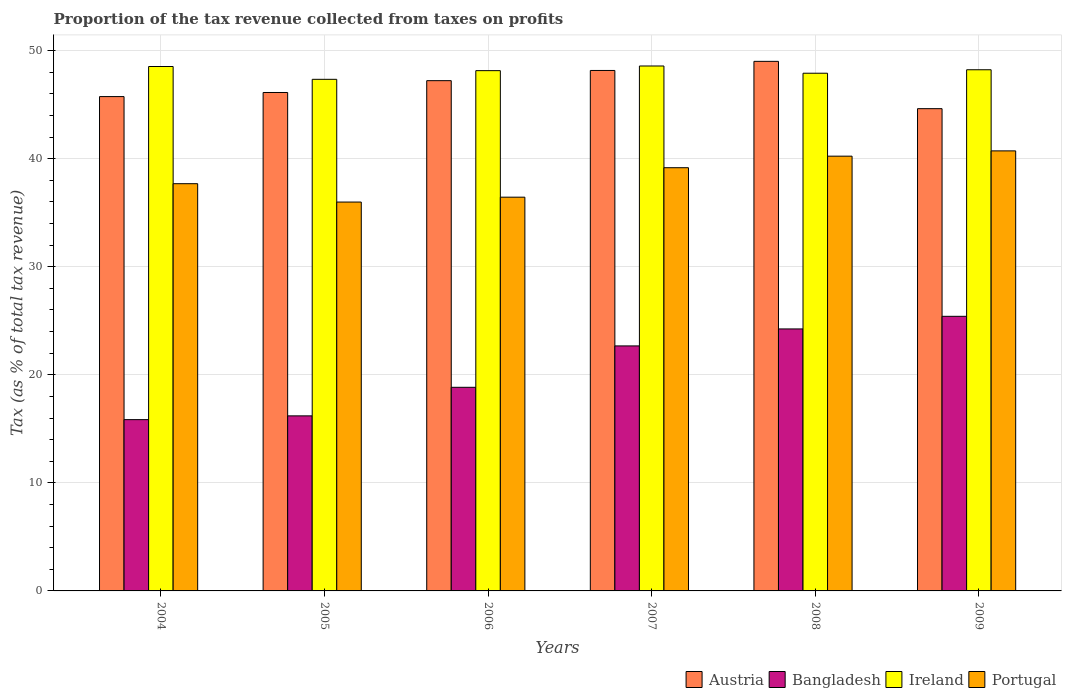How many groups of bars are there?
Your response must be concise. 6. Are the number of bars per tick equal to the number of legend labels?
Your response must be concise. Yes. Are the number of bars on each tick of the X-axis equal?
Your answer should be very brief. Yes. What is the label of the 6th group of bars from the left?
Your answer should be very brief. 2009. In how many cases, is the number of bars for a given year not equal to the number of legend labels?
Provide a short and direct response. 0. What is the proportion of the tax revenue collected in Austria in 2007?
Offer a very short reply. 48.16. Across all years, what is the maximum proportion of the tax revenue collected in Ireland?
Give a very brief answer. 48.57. Across all years, what is the minimum proportion of the tax revenue collected in Portugal?
Your answer should be very brief. 35.98. In which year was the proportion of the tax revenue collected in Ireland minimum?
Your answer should be compact. 2005. What is the total proportion of the tax revenue collected in Austria in the graph?
Provide a short and direct response. 280.87. What is the difference between the proportion of the tax revenue collected in Austria in 2004 and that in 2009?
Offer a terse response. 1.12. What is the difference between the proportion of the tax revenue collected in Ireland in 2005 and the proportion of the tax revenue collected in Portugal in 2004?
Your response must be concise. 9.66. What is the average proportion of the tax revenue collected in Austria per year?
Make the answer very short. 46.81. In the year 2009, what is the difference between the proportion of the tax revenue collected in Ireland and proportion of the tax revenue collected in Portugal?
Ensure brevity in your answer.  7.51. What is the ratio of the proportion of the tax revenue collected in Austria in 2004 to that in 2005?
Your answer should be compact. 0.99. Is the proportion of the tax revenue collected in Bangladesh in 2004 less than that in 2007?
Provide a short and direct response. Yes. Is the difference between the proportion of the tax revenue collected in Ireland in 2004 and 2006 greater than the difference between the proportion of the tax revenue collected in Portugal in 2004 and 2006?
Ensure brevity in your answer.  No. What is the difference between the highest and the second highest proportion of the tax revenue collected in Ireland?
Your answer should be very brief. 0.05. What is the difference between the highest and the lowest proportion of the tax revenue collected in Ireland?
Your answer should be compact. 1.23. Is the sum of the proportion of the tax revenue collected in Portugal in 2004 and 2006 greater than the maximum proportion of the tax revenue collected in Ireland across all years?
Your response must be concise. Yes. What does the 1st bar from the left in 2005 represents?
Ensure brevity in your answer.  Austria. How many bars are there?
Your response must be concise. 24. Are all the bars in the graph horizontal?
Ensure brevity in your answer.  No. What is the difference between two consecutive major ticks on the Y-axis?
Give a very brief answer. 10. Where does the legend appear in the graph?
Ensure brevity in your answer.  Bottom right. How many legend labels are there?
Give a very brief answer. 4. How are the legend labels stacked?
Your response must be concise. Horizontal. What is the title of the graph?
Your response must be concise. Proportion of the tax revenue collected from taxes on profits. What is the label or title of the X-axis?
Give a very brief answer. Years. What is the label or title of the Y-axis?
Provide a succinct answer. Tax (as % of total tax revenue). What is the Tax (as % of total tax revenue) of Austria in 2004?
Your response must be concise. 45.74. What is the Tax (as % of total tax revenue) in Bangladesh in 2004?
Offer a terse response. 15.85. What is the Tax (as % of total tax revenue) in Ireland in 2004?
Offer a very short reply. 48.53. What is the Tax (as % of total tax revenue) of Portugal in 2004?
Provide a succinct answer. 37.68. What is the Tax (as % of total tax revenue) of Austria in 2005?
Keep it short and to the point. 46.12. What is the Tax (as % of total tax revenue) of Bangladesh in 2005?
Ensure brevity in your answer.  16.2. What is the Tax (as % of total tax revenue) in Ireland in 2005?
Your answer should be compact. 47.34. What is the Tax (as % of total tax revenue) of Portugal in 2005?
Provide a succinct answer. 35.98. What is the Tax (as % of total tax revenue) of Austria in 2006?
Offer a terse response. 47.22. What is the Tax (as % of total tax revenue) in Bangladesh in 2006?
Provide a succinct answer. 18.84. What is the Tax (as % of total tax revenue) in Ireland in 2006?
Ensure brevity in your answer.  48.14. What is the Tax (as % of total tax revenue) of Portugal in 2006?
Ensure brevity in your answer.  36.43. What is the Tax (as % of total tax revenue) of Austria in 2007?
Provide a succinct answer. 48.16. What is the Tax (as % of total tax revenue) of Bangladesh in 2007?
Your response must be concise. 22.67. What is the Tax (as % of total tax revenue) in Ireland in 2007?
Make the answer very short. 48.57. What is the Tax (as % of total tax revenue) of Portugal in 2007?
Keep it short and to the point. 39.16. What is the Tax (as % of total tax revenue) of Austria in 2008?
Give a very brief answer. 49. What is the Tax (as % of total tax revenue) of Bangladesh in 2008?
Give a very brief answer. 24.24. What is the Tax (as % of total tax revenue) of Ireland in 2008?
Give a very brief answer. 47.9. What is the Tax (as % of total tax revenue) of Portugal in 2008?
Your answer should be very brief. 40.23. What is the Tax (as % of total tax revenue) of Austria in 2009?
Give a very brief answer. 44.63. What is the Tax (as % of total tax revenue) in Bangladesh in 2009?
Provide a succinct answer. 25.41. What is the Tax (as % of total tax revenue) in Ireland in 2009?
Ensure brevity in your answer.  48.22. What is the Tax (as % of total tax revenue) in Portugal in 2009?
Your answer should be very brief. 40.72. Across all years, what is the maximum Tax (as % of total tax revenue) of Austria?
Your answer should be compact. 49. Across all years, what is the maximum Tax (as % of total tax revenue) in Bangladesh?
Ensure brevity in your answer.  25.41. Across all years, what is the maximum Tax (as % of total tax revenue) in Ireland?
Ensure brevity in your answer.  48.57. Across all years, what is the maximum Tax (as % of total tax revenue) of Portugal?
Give a very brief answer. 40.72. Across all years, what is the minimum Tax (as % of total tax revenue) of Austria?
Provide a succinct answer. 44.63. Across all years, what is the minimum Tax (as % of total tax revenue) in Bangladesh?
Give a very brief answer. 15.85. Across all years, what is the minimum Tax (as % of total tax revenue) in Ireland?
Ensure brevity in your answer.  47.34. Across all years, what is the minimum Tax (as % of total tax revenue) of Portugal?
Provide a short and direct response. 35.98. What is the total Tax (as % of total tax revenue) in Austria in the graph?
Your answer should be compact. 280.87. What is the total Tax (as % of total tax revenue) in Bangladesh in the graph?
Offer a terse response. 123.21. What is the total Tax (as % of total tax revenue) of Ireland in the graph?
Provide a succinct answer. 288.71. What is the total Tax (as % of total tax revenue) of Portugal in the graph?
Your answer should be very brief. 230.21. What is the difference between the Tax (as % of total tax revenue) of Austria in 2004 and that in 2005?
Your response must be concise. -0.38. What is the difference between the Tax (as % of total tax revenue) of Bangladesh in 2004 and that in 2005?
Keep it short and to the point. -0.35. What is the difference between the Tax (as % of total tax revenue) in Ireland in 2004 and that in 2005?
Offer a terse response. 1.19. What is the difference between the Tax (as % of total tax revenue) of Portugal in 2004 and that in 2005?
Provide a short and direct response. 1.7. What is the difference between the Tax (as % of total tax revenue) of Austria in 2004 and that in 2006?
Make the answer very short. -1.47. What is the difference between the Tax (as % of total tax revenue) of Bangladesh in 2004 and that in 2006?
Offer a very short reply. -2.99. What is the difference between the Tax (as % of total tax revenue) of Ireland in 2004 and that in 2006?
Offer a terse response. 0.38. What is the difference between the Tax (as % of total tax revenue) of Portugal in 2004 and that in 2006?
Offer a terse response. 1.25. What is the difference between the Tax (as % of total tax revenue) in Austria in 2004 and that in 2007?
Provide a short and direct response. -2.42. What is the difference between the Tax (as % of total tax revenue) of Bangladesh in 2004 and that in 2007?
Your answer should be compact. -6.82. What is the difference between the Tax (as % of total tax revenue) of Ireland in 2004 and that in 2007?
Provide a short and direct response. -0.05. What is the difference between the Tax (as % of total tax revenue) of Portugal in 2004 and that in 2007?
Your answer should be compact. -1.48. What is the difference between the Tax (as % of total tax revenue) in Austria in 2004 and that in 2008?
Your response must be concise. -3.26. What is the difference between the Tax (as % of total tax revenue) of Bangladesh in 2004 and that in 2008?
Your response must be concise. -8.39. What is the difference between the Tax (as % of total tax revenue) of Ireland in 2004 and that in 2008?
Keep it short and to the point. 0.62. What is the difference between the Tax (as % of total tax revenue) in Portugal in 2004 and that in 2008?
Give a very brief answer. -2.55. What is the difference between the Tax (as % of total tax revenue) in Austria in 2004 and that in 2009?
Your answer should be compact. 1.12. What is the difference between the Tax (as % of total tax revenue) in Bangladesh in 2004 and that in 2009?
Offer a terse response. -9.56. What is the difference between the Tax (as % of total tax revenue) in Ireland in 2004 and that in 2009?
Your answer should be compact. 0.3. What is the difference between the Tax (as % of total tax revenue) of Portugal in 2004 and that in 2009?
Make the answer very short. -3.04. What is the difference between the Tax (as % of total tax revenue) in Austria in 2005 and that in 2006?
Ensure brevity in your answer.  -1.1. What is the difference between the Tax (as % of total tax revenue) of Bangladesh in 2005 and that in 2006?
Provide a succinct answer. -2.64. What is the difference between the Tax (as % of total tax revenue) in Ireland in 2005 and that in 2006?
Keep it short and to the point. -0.8. What is the difference between the Tax (as % of total tax revenue) in Portugal in 2005 and that in 2006?
Provide a succinct answer. -0.45. What is the difference between the Tax (as % of total tax revenue) in Austria in 2005 and that in 2007?
Give a very brief answer. -2.04. What is the difference between the Tax (as % of total tax revenue) of Bangladesh in 2005 and that in 2007?
Keep it short and to the point. -6.47. What is the difference between the Tax (as % of total tax revenue) in Ireland in 2005 and that in 2007?
Make the answer very short. -1.23. What is the difference between the Tax (as % of total tax revenue) of Portugal in 2005 and that in 2007?
Ensure brevity in your answer.  -3.18. What is the difference between the Tax (as % of total tax revenue) of Austria in 2005 and that in 2008?
Ensure brevity in your answer.  -2.88. What is the difference between the Tax (as % of total tax revenue) in Bangladesh in 2005 and that in 2008?
Your answer should be very brief. -8.04. What is the difference between the Tax (as % of total tax revenue) of Ireland in 2005 and that in 2008?
Provide a succinct answer. -0.56. What is the difference between the Tax (as % of total tax revenue) of Portugal in 2005 and that in 2008?
Give a very brief answer. -4.25. What is the difference between the Tax (as % of total tax revenue) of Austria in 2005 and that in 2009?
Offer a terse response. 1.5. What is the difference between the Tax (as % of total tax revenue) of Bangladesh in 2005 and that in 2009?
Your answer should be very brief. -9.21. What is the difference between the Tax (as % of total tax revenue) in Ireland in 2005 and that in 2009?
Ensure brevity in your answer.  -0.88. What is the difference between the Tax (as % of total tax revenue) of Portugal in 2005 and that in 2009?
Ensure brevity in your answer.  -4.73. What is the difference between the Tax (as % of total tax revenue) of Austria in 2006 and that in 2007?
Your response must be concise. -0.94. What is the difference between the Tax (as % of total tax revenue) in Bangladesh in 2006 and that in 2007?
Ensure brevity in your answer.  -3.83. What is the difference between the Tax (as % of total tax revenue) of Ireland in 2006 and that in 2007?
Make the answer very short. -0.43. What is the difference between the Tax (as % of total tax revenue) in Portugal in 2006 and that in 2007?
Offer a very short reply. -2.73. What is the difference between the Tax (as % of total tax revenue) of Austria in 2006 and that in 2008?
Provide a succinct answer. -1.79. What is the difference between the Tax (as % of total tax revenue) of Bangladesh in 2006 and that in 2008?
Your answer should be compact. -5.4. What is the difference between the Tax (as % of total tax revenue) in Ireland in 2006 and that in 2008?
Offer a very short reply. 0.24. What is the difference between the Tax (as % of total tax revenue) in Portugal in 2006 and that in 2008?
Make the answer very short. -3.8. What is the difference between the Tax (as % of total tax revenue) in Austria in 2006 and that in 2009?
Provide a short and direct response. 2.59. What is the difference between the Tax (as % of total tax revenue) in Bangladesh in 2006 and that in 2009?
Offer a terse response. -6.57. What is the difference between the Tax (as % of total tax revenue) in Ireland in 2006 and that in 2009?
Provide a succinct answer. -0.08. What is the difference between the Tax (as % of total tax revenue) of Portugal in 2006 and that in 2009?
Provide a succinct answer. -4.28. What is the difference between the Tax (as % of total tax revenue) in Austria in 2007 and that in 2008?
Make the answer very short. -0.84. What is the difference between the Tax (as % of total tax revenue) in Bangladesh in 2007 and that in 2008?
Make the answer very short. -1.57. What is the difference between the Tax (as % of total tax revenue) of Ireland in 2007 and that in 2008?
Offer a terse response. 0.67. What is the difference between the Tax (as % of total tax revenue) in Portugal in 2007 and that in 2008?
Keep it short and to the point. -1.07. What is the difference between the Tax (as % of total tax revenue) of Austria in 2007 and that in 2009?
Make the answer very short. 3.53. What is the difference between the Tax (as % of total tax revenue) of Bangladesh in 2007 and that in 2009?
Provide a short and direct response. -2.74. What is the difference between the Tax (as % of total tax revenue) of Ireland in 2007 and that in 2009?
Your response must be concise. 0.35. What is the difference between the Tax (as % of total tax revenue) in Portugal in 2007 and that in 2009?
Provide a succinct answer. -1.56. What is the difference between the Tax (as % of total tax revenue) of Austria in 2008 and that in 2009?
Give a very brief answer. 4.38. What is the difference between the Tax (as % of total tax revenue) of Bangladesh in 2008 and that in 2009?
Keep it short and to the point. -1.17. What is the difference between the Tax (as % of total tax revenue) in Ireland in 2008 and that in 2009?
Your answer should be compact. -0.32. What is the difference between the Tax (as % of total tax revenue) of Portugal in 2008 and that in 2009?
Keep it short and to the point. -0.49. What is the difference between the Tax (as % of total tax revenue) of Austria in 2004 and the Tax (as % of total tax revenue) of Bangladesh in 2005?
Make the answer very short. 29.54. What is the difference between the Tax (as % of total tax revenue) of Austria in 2004 and the Tax (as % of total tax revenue) of Ireland in 2005?
Your answer should be very brief. -1.6. What is the difference between the Tax (as % of total tax revenue) of Austria in 2004 and the Tax (as % of total tax revenue) of Portugal in 2005?
Your answer should be compact. 9.76. What is the difference between the Tax (as % of total tax revenue) of Bangladesh in 2004 and the Tax (as % of total tax revenue) of Ireland in 2005?
Make the answer very short. -31.49. What is the difference between the Tax (as % of total tax revenue) in Bangladesh in 2004 and the Tax (as % of total tax revenue) in Portugal in 2005?
Offer a terse response. -20.13. What is the difference between the Tax (as % of total tax revenue) of Ireland in 2004 and the Tax (as % of total tax revenue) of Portugal in 2005?
Give a very brief answer. 12.54. What is the difference between the Tax (as % of total tax revenue) of Austria in 2004 and the Tax (as % of total tax revenue) of Bangladesh in 2006?
Provide a short and direct response. 26.9. What is the difference between the Tax (as % of total tax revenue) in Austria in 2004 and the Tax (as % of total tax revenue) in Ireland in 2006?
Your answer should be compact. -2.4. What is the difference between the Tax (as % of total tax revenue) in Austria in 2004 and the Tax (as % of total tax revenue) in Portugal in 2006?
Provide a short and direct response. 9.31. What is the difference between the Tax (as % of total tax revenue) in Bangladesh in 2004 and the Tax (as % of total tax revenue) in Ireland in 2006?
Your answer should be compact. -32.29. What is the difference between the Tax (as % of total tax revenue) of Bangladesh in 2004 and the Tax (as % of total tax revenue) of Portugal in 2006?
Your response must be concise. -20.58. What is the difference between the Tax (as % of total tax revenue) in Ireland in 2004 and the Tax (as % of total tax revenue) in Portugal in 2006?
Your answer should be compact. 12.09. What is the difference between the Tax (as % of total tax revenue) of Austria in 2004 and the Tax (as % of total tax revenue) of Bangladesh in 2007?
Ensure brevity in your answer.  23.07. What is the difference between the Tax (as % of total tax revenue) in Austria in 2004 and the Tax (as % of total tax revenue) in Ireland in 2007?
Give a very brief answer. -2.83. What is the difference between the Tax (as % of total tax revenue) in Austria in 2004 and the Tax (as % of total tax revenue) in Portugal in 2007?
Offer a terse response. 6.58. What is the difference between the Tax (as % of total tax revenue) in Bangladesh in 2004 and the Tax (as % of total tax revenue) in Ireland in 2007?
Provide a succinct answer. -32.72. What is the difference between the Tax (as % of total tax revenue) of Bangladesh in 2004 and the Tax (as % of total tax revenue) of Portugal in 2007?
Keep it short and to the point. -23.31. What is the difference between the Tax (as % of total tax revenue) of Ireland in 2004 and the Tax (as % of total tax revenue) of Portugal in 2007?
Ensure brevity in your answer.  9.36. What is the difference between the Tax (as % of total tax revenue) in Austria in 2004 and the Tax (as % of total tax revenue) in Bangladesh in 2008?
Offer a terse response. 21.5. What is the difference between the Tax (as % of total tax revenue) in Austria in 2004 and the Tax (as % of total tax revenue) in Ireland in 2008?
Keep it short and to the point. -2.16. What is the difference between the Tax (as % of total tax revenue) of Austria in 2004 and the Tax (as % of total tax revenue) of Portugal in 2008?
Provide a succinct answer. 5.51. What is the difference between the Tax (as % of total tax revenue) of Bangladesh in 2004 and the Tax (as % of total tax revenue) of Ireland in 2008?
Give a very brief answer. -32.05. What is the difference between the Tax (as % of total tax revenue) in Bangladesh in 2004 and the Tax (as % of total tax revenue) in Portugal in 2008?
Offer a very short reply. -24.38. What is the difference between the Tax (as % of total tax revenue) of Ireland in 2004 and the Tax (as % of total tax revenue) of Portugal in 2008?
Offer a terse response. 8.3. What is the difference between the Tax (as % of total tax revenue) in Austria in 2004 and the Tax (as % of total tax revenue) in Bangladesh in 2009?
Your response must be concise. 20.33. What is the difference between the Tax (as % of total tax revenue) of Austria in 2004 and the Tax (as % of total tax revenue) of Ireland in 2009?
Provide a short and direct response. -2.48. What is the difference between the Tax (as % of total tax revenue) in Austria in 2004 and the Tax (as % of total tax revenue) in Portugal in 2009?
Make the answer very short. 5.02. What is the difference between the Tax (as % of total tax revenue) of Bangladesh in 2004 and the Tax (as % of total tax revenue) of Ireland in 2009?
Offer a terse response. -32.37. What is the difference between the Tax (as % of total tax revenue) of Bangladesh in 2004 and the Tax (as % of total tax revenue) of Portugal in 2009?
Offer a very short reply. -24.87. What is the difference between the Tax (as % of total tax revenue) of Ireland in 2004 and the Tax (as % of total tax revenue) of Portugal in 2009?
Provide a short and direct response. 7.81. What is the difference between the Tax (as % of total tax revenue) of Austria in 2005 and the Tax (as % of total tax revenue) of Bangladesh in 2006?
Offer a very short reply. 27.28. What is the difference between the Tax (as % of total tax revenue) in Austria in 2005 and the Tax (as % of total tax revenue) in Ireland in 2006?
Offer a terse response. -2.02. What is the difference between the Tax (as % of total tax revenue) of Austria in 2005 and the Tax (as % of total tax revenue) of Portugal in 2006?
Offer a terse response. 9.69. What is the difference between the Tax (as % of total tax revenue) in Bangladesh in 2005 and the Tax (as % of total tax revenue) in Ireland in 2006?
Offer a very short reply. -31.94. What is the difference between the Tax (as % of total tax revenue) in Bangladesh in 2005 and the Tax (as % of total tax revenue) in Portugal in 2006?
Ensure brevity in your answer.  -20.23. What is the difference between the Tax (as % of total tax revenue) in Ireland in 2005 and the Tax (as % of total tax revenue) in Portugal in 2006?
Your answer should be very brief. 10.91. What is the difference between the Tax (as % of total tax revenue) of Austria in 2005 and the Tax (as % of total tax revenue) of Bangladesh in 2007?
Your answer should be compact. 23.45. What is the difference between the Tax (as % of total tax revenue) in Austria in 2005 and the Tax (as % of total tax revenue) in Ireland in 2007?
Provide a short and direct response. -2.45. What is the difference between the Tax (as % of total tax revenue) in Austria in 2005 and the Tax (as % of total tax revenue) in Portugal in 2007?
Keep it short and to the point. 6.96. What is the difference between the Tax (as % of total tax revenue) in Bangladesh in 2005 and the Tax (as % of total tax revenue) in Ireland in 2007?
Provide a succinct answer. -32.37. What is the difference between the Tax (as % of total tax revenue) in Bangladesh in 2005 and the Tax (as % of total tax revenue) in Portugal in 2007?
Give a very brief answer. -22.96. What is the difference between the Tax (as % of total tax revenue) of Ireland in 2005 and the Tax (as % of total tax revenue) of Portugal in 2007?
Provide a succinct answer. 8.18. What is the difference between the Tax (as % of total tax revenue) in Austria in 2005 and the Tax (as % of total tax revenue) in Bangladesh in 2008?
Make the answer very short. 21.88. What is the difference between the Tax (as % of total tax revenue) in Austria in 2005 and the Tax (as % of total tax revenue) in Ireland in 2008?
Give a very brief answer. -1.78. What is the difference between the Tax (as % of total tax revenue) of Austria in 2005 and the Tax (as % of total tax revenue) of Portugal in 2008?
Ensure brevity in your answer.  5.89. What is the difference between the Tax (as % of total tax revenue) of Bangladesh in 2005 and the Tax (as % of total tax revenue) of Ireland in 2008?
Provide a succinct answer. -31.7. What is the difference between the Tax (as % of total tax revenue) of Bangladesh in 2005 and the Tax (as % of total tax revenue) of Portugal in 2008?
Make the answer very short. -24.03. What is the difference between the Tax (as % of total tax revenue) of Ireland in 2005 and the Tax (as % of total tax revenue) of Portugal in 2008?
Provide a short and direct response. 7.11. What is the difference between the Tax (as % of total tax revenue) in Austria in 2005 and the Tax (as % of total tax revenue) in Bangladesh in 2009?
Offer a terse response. 20.71. What is the difference between the Tax (as % of total tax revenue) of Austria in 2005 and the Tax (as % of total tax revenue) of Ireland in 2009?
Make the answer very short. -2.1. What is the difference between the Tax (as % of total tax revenue) of Austria in 2005 and the Tax (as % of total tax revenue) of Portugal in 2009?
Offer a terse response. 5.4. What is the difference between the Tax (as % of total tax revenue) in Bangladesh in 2005 and the Tax (as % of total tax revenue) in Ireland in 2009?
Keep it short and to the point. -32.03. What is the difference between the Tax (as % of total tax revenue) of Bangladesh in 2005 and the Tax (as % of total tax revenue) of Portugal in 2009?
Offer a very short reply. -24.52. What is the difference between the Tax (as % of total tax revenue) of Ireland in 2005 and the Tax (as % of total tax revenue) of Portugal in 2009?
Your answer should be compact. 6.62. What is the difference between the Tax (as % of total tax revenue) of Austria in 2006 and the Tax (as % of total tax revenue) of Bangladesh in 2007?
Offer a terse response. 24.55. What is the difference between the Tax (as % of total tax revenue) of Austria in 2006 and the Tax (as % of total tax revenue) of Ireland in 2007?
Give a very brief answer. -1.36. What is the difference between the Tax (as % of total tax revenue) of Austria in 2006 and the Tax (as % of total tax revenue) of Portugal in 2007?
Keep it short and to the point. 8.05. What is the difference between the Tax (as % of total tax revenue) in Bangladesh in 2006 and the Tax (as % of total tax revenue) in Ireland in 2007?
Make the answer very short. -29.73. What is the difference between the Tax (as % of total tax revenue) in Bangladesh in 2006 and the Tax (as % of total tax revenue) in Portugal in 2007?
Make the answer very short. -20.32. What is the difference between the Tax (as % of total tax revenue) in Ireland in 2006 and the Tax (as % of total tax revenue) in Portugal in 2007?
Give a very brief answer. 8.98. What is the difference between the Tax (as % of total tax revenue) of Austria in 2006 and the Tax (as % of total tax revenue) of Bangladesh in 2008?
Provide a succinct answer. 22.97. What is the difference between the Tax (as % of total tax revenue) in Austria in 2006 and the Tax (as % of total tax revenue) in Ireland in 2008?
Give a very brief answer. -0.69. What is the difference between the Tax (as % of total tax revenue) in Austria in 2006 and the Tax (as % of total tax revenue) in Portugal in 2008?
Provide a short and direct response. 6.99. What is the difference between the Tax (as % of total tax revenue) in Bangladesh in 2006 and the Tax (as % of total tax revenue) in Ireland in 2008?
Ensure brevity in your answer.  -29.06. What is the difference between the Tax (as % of total tax revenue) of Bangladesh in 2006 and the Tax (as % of total tax revenue) of Portugal in 2008?
Keep it short and to the point. -21.39. What is the difference between the Tax (as % of total tax revenue) of Ireland in 2006 and the Tax (as % of total tax revenue) of Portugal in 2008?
Your answer should be very brief. 7.91. What is the difference between the Tax (as % of total tax revenue) in Austria in 2006 and the Tax (as % of total tax revenue) in Bangladesh in 2009?
Keep it short and to the point. 21.81. What is the difference between the Tax (as % of total tax revenue) of Austria in 2006 and the Tax (as % of total tax revenue) of Ireland in 2009?
Your answer should be compact. -1.01. What is the difference between the Tax (as % of total tax revenue) in Austria in 2006 and the Tax (as % of total tax revenue) in Portugal in 2009?
Provide a short and direct response. 6.5. What is the difference between the Tax (as % of total tax revenue) of Bangladesh in 2006 and the Tax (as % of total tax revenue) of Ireland in 2009?
Keep it short and to the point. -29.38. What is the difference between the Tax (as % of total tax revenue) in Bangladesh in 2006 and the Tax (as % of total tax revenue) in Portugal in 2009?
Your response must be concise. -21.88. What is the difference between the Tax (as % of total tax revenue) of Ireland in 2006 and the Tax (as % of total tax revenue) of Portugal in 2009?
Give a very brief answer. 7.42. What is the difference between the Tax (as % of total tax revenue) of Austria in 2007 and the Tax (as % of total tax revenue) of Bangladesh in 2008?
Give a very brief answer. 23.92. What is the difference between the Tax (as % of total tax revenue) in Austria in 2007 and the Tax (as % of total tax revenue) in Ireland in 2008?
Offer a very short reply. 0.26. What is the difference between the Tax (as % of total tax revenue) of Austria in 2007 and the Tax (as % of total tax revenue) of Portugal in 2008?
Provide a short and direct response. 7.93. What is the difference between the Tax (as % of total tax revenue) of Bangladesh in 2007 and the Tax (as % of total tax revenue) of Ireland in 2008?
Make the answer very short. -25.23. What is the difference between the Tax (as % of total tax revenue) in Bangladesh in 2007 and the Tax (as % of total tax revenue) in Portugal in 2008?
Your answer should be very brief. -17.56. What is the difference between the Tax (as % of total tax revenue) of Ireland in 2007 and the Tax (as % of total tax revenue) of Portugal in 2008?
Offer a very short reply. 8.34. What is the difference between the Tax (as % of total tax revenue) of Austria in 2007 and the Tax (as % of total tax revenue) of Bangladesh in 2009?
Keep it short and to the point. 22.75. What is the difference between the Tax (as % of total tax revenue) in Austria in 2007 and the Tax (as % of total tax revenue) in Ireland in 2009?
Offer a terse response. -0.07. What is the difference between the Tax (as % of total tax revenue) in Austria in 2007 and the Tax (as % of total tax revenue) in Portugal in 2009?
Keep it short and to the point. 7.44. What is the difference between the Tax (as % of total tax revenue) in Bangladesh in 2007 and the Tax (as % of total tax revenue) in Ireland in 2009?
Your response must be concise. -25.55. What is the difference between the Tax (as % of total tax revenue) of Bangladesh in 2007 and the Tax (as % of total tax revenue) of Portugal in 2009?
Ensure brevity in your answer.  -18.05. What is the difference between the Tax (as % of total tax revenue) in Ireland in 2007 and the Tax (as % of total tax revenue) in Portugal in 2009?
Offer a very short reply. 7.86. What is the difference between the Tax (as % of total tax revenue) in Austria in 2008 and the Tax (as % of total tax revenue) in Bangladesh in 2009?
Your answer should be very brief. 23.59. What is the difference between the Tax (as % of total tax revenue) of Austria in 2008 and the Tax (as % of total tax revenue) of Ireland in 2009?
Provide a short and direct response. 0.78. What is the difference between the Tax (as % of total tax revenue) in Austria in 2008 and the Tax (as % of total tax revenue) in Portugal in 2009?
Make the answer very short. 8.28. What is the difference between the Tax (as % of total tax revenue) of Bangladesh in 2008 and the Tax (as % of total tax revenue) of Ireland in 2009?
Your answer should be compact. -23.98. What is the difference between the Tax (as % of total tax revenue) of Bangladesh in 2008 and the Tax (as % of total tax revenue) of Portugal in 2009?
Give a very brief answer. -16.48. What is the difference between the Tax (as % of total tax revenue) in Ireland in 2008 and the Tax (as % of total tax revenue) in Portugal in 2009?
Your response must be concise. 7.19. What is the average Tax (as % of total tax revenue) in Austria per year?
Offer a very short reply. 46.81. What is the average Tax (as % of total tax revenue) in Bangladesh per year?
Offer a very short reply. 20.54. What is the average Tax (as % of total tax revenue) of Ireland per year?
Keep it short and to the point. 48.12. What is the average Tax (as % of total tax revenue) of Portugal per year?
Make the answer very short. 38.37. In the year 2004, what is the difference between the Tax (as % of total tax revenue) of Austria and Tax (as % of total tax revenue) of Bangladesh?
Give a very brief answer. 29.89. In the year 2004, what is the difference between the Tax (as % of total tax revenue) in Austria and Tax (as % of total tax revenue) in Ireland?
Ensure brevity in your answer.  -2.78. In the year 2004, what is the difference between the Tax (as % of total tax revenue) in Austria and Tax (as % of total tax revenue) in Portugal?
Your answer should be very brief. 8.06. In the year 2004, what is the difference between the Tax (as % of total tax revenue) of Bangladesh and Tax (as % of total tax revenue) of Ireland?
Ensure brevity in your answer.  -32.67. In the year 2004, what is the difference between the Tax (as % of total tax revenue) in Bangladesh and Tax (as % of total tax revenue) in Portugal?
Offer a very short reply. -21.83. In the year 2004, what is the difference between the Tax (as % of total tax revenue) of Ireland and Tax (as % of total tax revenue) of Portugal?
Your answer should be very brief. 10.84. In the year 2005, what is the difference between the Tax (as % of total tax revenue) in Austria and Tax (as % of total tax revenue) in Bangladesh?
Provide a succinct answer. 29.92. In the year 2005, what is the difference between the Tax (as % of total tax revenue) in Austria and Tax (as % of total tax revenue) in Ireland?
Give a very brief answer. -1.22. In the year 2005, what is the difference between the Tax (as % of total tax revenue) in Austria and Tax (as % of total tax revenue) in Portugal?
Provide a succinct answer. 10.14. In the year 2005, what is the difference between the Tax (as % of total tax revenue) of Bangladesh and Tax (as % of total tax revenue) of Ireland?
Offer a terse response. -31.14. In the year 2005, what is the difference between the Tax (as % of total tax revenue) of Bangladesh and Tax (as % of total tax revenue) of Portugal?
Keep it short and to the point. -19.78. In the year 2005, what is the difference between the Tax (as % of total tax revenue) in Ireland and Tax (as % of total tax revenue) in Portugal?
Your answer should be very brief. 11.36. In the year 2006, what is the difference between the Tax (as % of total tax revenue) of Austria and Tax (as % of total tax revenue) of Bangladesh?
Give a very brief answer. 28.38. In the year 2006, what is the difference between the Tax (as % of total tax revenue) in Austria and Tax (as % of total tax revenue) in Ireland?
Provide a short and direct response. -0.93. In the year 2006, what is the difference between the Tax (as % of total tax revenue) in Austria and Tax (as % of total tax revenue) in Portugal?
Your response must be concise. 10.78. In the year 2006, what is the difference between the Tax (as % of total tax revenue) in Bangladesh and Tax (as % of total tax revenue) in Ireland?
Give a very brief answer. -29.3. In the year 2006, what is the difference between the Tax (as % of total tax revenue) in Bangladesh and Tax (as % of total tax revenue) in Portugal?
Provide a short and direct response. -17.59. In the year 2006, what is the difference between the Tax (as % of total tax revenue) of Ireland and Tax (as % of total tax revenue) of Portugal?
Your answer should be very brief. 11.71. In the year 2007, what is the difference between the Tax (as % of total tax revenue) of Austria and Tax (as % of total tax revenue) of Bangladesh?
Offer a very short reply. 25.49. In the year 2007, what is the difference between the Tax (as % of total tax revenue) in Austria and Tax (as % of total tax revenue) in Ireland?
Offer a terse response. -0.41. In the year 2007, what is the difference between the Tax (as % of total tax revenue) in Austria and Tax (as % of total tax revenue) in Portugal?
Offer a very short reply. 9. In the year 2007, what is the difference between the Tax (as % of total tax revenue) of Bangladesh and Tax (as % of total tax revenue) of Ireland?
Ensure brevity in your answer.  -25.9. In the year 2007, what is the difference between the Tax (as % of total tax revenue) of Bangladesh and Tax (as % of total tax revenue) of Portugal?
Make the answer very short. -16.49. In the year 2007, what is the difference between the Tax (as % of total tax revenue) of Ireland and Tax (as % of total tax revenue) of Portugal?
Ensure brevity in your answer.  9.41. In the year 2008, what is the difference between the Tax (as % of total tax revenue) of Austria and Tax (as % of total tax revenue) of Bangladesh?
Offer a terse response. 24.76. In the year 2008, what is the difference between the Tax (as % of total tax revenue) in Austria and Tax (as % of total tax revenue) in Ireland?
Keep it short and to the point. 1.1. In the year 2008, what is the difference between the Tax (as % of total tax revenue) of Austria and Tax (as % of total tax revenue) of Portugal?
Offer a terse response. 8.77. In the year 2008, what is the difference between the Tax (as % of total tax revenue) in Bangladesh and Tax (as % of total tax revenue) in Ireland?
Your answer should be compact. -23.66. In the year 2008, what is the difference between the Tax (as % of total tax revenue) of Bangladesh and Tax (as % of total tax revenue) of Portugal?
Make the answer very short. -15.99. In the year 2008, what is the difference between the Tax (as % of total tax revenue) in Ireland and Tax (as % of total tax revenue) in Portugal?
Give a very brief answer. 7.67. In the year 2009, what is the difference between the Tax (as % of total tax revenue) in Austria and Tax (as % of total tax revenue) in Bangladesh?
Give a very brief answer. 19.22. In the year 2009, what is the difference between the Tax (as % of total tax revenue) of Austria and Tax (as % of total tax revenue) of Ireland?
Ensure brevity in your answer.  -3.6. In the year 2009, what is the difference between the Tax (as % of total tax revenue) of Austria and Tax (as % of total tax revenue) of Portugal?
Ensure brevity in your answer.  3.91. In the year 2009, what is the difference between the Tax (as % of total tax revenue) of Bangladesh and Tax (as % of total tax revenue) of Ireland?
Your answer should be very brief. -22.81. In the year 2009, what is the difference between the Tax (as % of total tax revenue) in Bangladesh and Tax (as % of total tax revenue) in Portugal?
Provide a short and direct response. -15.31. In the year 2009, what is the difference between the Tax (as % of total tax revenue) in Ireland and Tax (as % of total tax revenue) in Portugal?
Keep it short and to the point. 7.51. What is the ratio of the Tax (as % of total tax revenue) in Bangladesh in 2004 to that in 2005?
Your answer should be very brief. 0.98. What is the ratio of the Tax (as % of total tax revenue) in Ireland in 2004 to that in 2005?
Offer a terse response. 1.02. What is the ratio of the Tax (as % of total tax revenue) of Portugal in 2004 to that in 2005?
Ensure brevity in your answer.  1.05. What is the ratio of the Tax (as % of total tax revenue) in Austria in 2004 to that in 2006?
Ensure brevity in your answer.  0.97. What is the ratio of the Tax (as % of total tax revenue) of Bangladesh in 2004 to that in 2006?
Give a very brief answer. 0.84. What is the ratio of the Tax (as % of total tax revenue) in Ireland in 2004 to that in 2006?
Make the answer very short. 1.01. What is the ratio of the Tax (as % of total tax revenue) in Portugal in 2004 to that in 2006?
Provide a short and direct response. 1.03. What is the ratio of the Tax (as % of total tax revenue) of Austria in 2004 to that in 2007?
Offer a very short reply. 0.95. What is the ratio of the Tax (as % of total tax revenue) in Bangladesh in 2004 to that in 2007?
Your answer should be very brief. 0.7. What is the ratio of the Tax (as % of total tax revenue) of Portugal in 2004 to that in 2007?
Give a very brief answer. 0.96. What is the ratio of the Tax (as % of total tax revenue) of Austria in 2004 to that in 2008?
Provide a succinct answer. 0.93. What is the ratio of the Tax (as % of total tax revenue) of Bangladesh in 2004 to that in 2008?
Make the answer very short. 0.65. What is the ratio of the Tax (as % of total tax revenue) in Ireland in 2004 to that in 2008?
Keep it short and to the point. 1.01. What is the ratio of the Tax (as % of total tax revenue) in Portugal in 2004 to that in 2008?
Provide a succinct answer. 0.94. What is the ratio of the Tax (as % of total tax revenue) in Austria in 2004 to that in 2009?
Provide a short and direct response. 1.02. What is the ratio of the Tax (as % of total tax revenue) of Bangladesh in 2004 to that in 2009?
Ensure brevity in your answer.  0.62. What is the ratio of the Tax (as % of total tax revenue) in Portugal in 2004 to that in 2009?
Give a very brief answer. 0.93. What is the ratio of the Tax (as % of total tax revenue) in Austria in 2005 to that in 2006?
Offer a terse response. 0.98. What is the ratio of the Tax (as % of total tax revenue) in Bangladesh in 2005 to that in 2006?
Keep it short and to the point. 0.86. What is the ratio of the Tax (as % of total tax revenue) in Ireland in 2005 to that in 2006?
Keep it short and to the point. 0.98. What is the ratio of the Tax (as % of total tax revenue) in Portugal in 2005 to that in 2006?
Provide a succinct answer. 0.99. What is the ratio of the Tax (as % of total tax revenue) in Austria in 2005 to that in 2007?
Offer a terse response. 0.96. What is the ratio of the Tax (as % of total tax revenue) of Bangladesh in 2005 to that in 2007?
Ensure brevity in your answer.  0.71. What is the ratio of the Tax (as % of total tax revenue) in Ireland in 2005 to that in 2007?
Make the answer very short. 0.97. What is the ratio of the Tax (as % of total tax revenue) of Portugal in 2005 to that in 2007?
Your response must be concise. 0.92. What is the ratio of the Tax (as % of total tax revenue) in Austria in 2005 to that in 2008?
Provide a short and direct response. 0.94. What is the ratio of the Tax (as % of total tax revenue) in Bangladesh in 2005 to that in 2008?
Give a very brief answer. 0.67. What is the ratio of the Tax (as % of total tax revenue) of Ireland in 2005 to that in 2008?
Offer a very short reply. 0.99. What is the ratio of the Tax (as % of total tax revenue) in Portugal in 2005 to that in 2008?
Make the answer very short. 0.89. What is the ratio of the Tax (as % of total tax revenue) of Austria in 2005 to that in 2009?
Keep it short and to the point. 1.03. What is the ratio of the Tax (as % of total tax revenue) in Bangladesh in 2005 to that in 2009?
Your answer should be very brief. 0.64. What is the ratio of the Tax (as % of total tax revenue) in Ireland in 2005 to that in 2009?
Offer a very short reply. 0.98. What is the ratio of the Tax (as % of total tax revenue) of Portugal in 2005 to that in 2009?
Ensure brevity in your answer.  0.88. What is the ratio of the Tax (as % of total tax revenue) of Austria in 2006 to that in 2007?
Offer a very short reply. 0.98. What is the ratio of the Tax (as % of total tax revenue) in Bangladesh in 2006 to that in 2007?
Offer a terse response. 0.83. What is the ratio of the Tax (as % of total tax revenue) in Ireland in 2006 to that in 2007?
Provide a short and direct response. 0.99. What is the ratio of the Tax (as % of total tax revenue) of Portugal in 2006 to that in 2007?
Provide a succinct answer. 0.93. What is the ratio of the Tax (as % of total tax revenue) in Austria in 2006 to that in 2008?
Offer a very short reply. 0.96. What is the ratio of the Tax (as % of total tax revenue) in Bangladesh in 2006 to that in 2008?
Keep it short and to the point. 0.78. What is the ratio of the Tax (as % of total tax revenue) in Ireland in 2006 to that in 2008?
Provide a short and direct response. 1. What is the ratio of the Tax (as % of total tax revenue) in Portugal in 2006 to that in 2008?
Ensure brevity in your answer.  0.91. What is the ratio of the Tax (as % of total tax revenue) of Austria in 2006 to that in 2009?
Give a very brief answer. 1.06. What is the ratio of the Tax (as % of total tax revenue) of Bangladesh in 2006 to that in 2009?
Offer a very short reply. 0.74. What is the ratio of the Tax (as % of total tax revenue) of Portugal in 2006 to that in 2009?
Offer a terse response. 0.89. What is the ratio of the Tax (as % of total tax revenue) in Austria in 2007 to that in 2008?
Ensure brevity in your answer.  0.98. What is the ratio of the Tax (as % of total tax revenue) in Bangladesh in 2007 to that in 2008?
Provide a short and direct response. 0.94. What is the ratio of the Tax (as % of total tax revenue) of Ireland in 2007 to that in 2008?
Your answer should be very brief. 1.01. What is the ratio of the Tax (as % of total tax revenue) in Portugal in 2007 to that in 2008?
Offer a very short reply. 0.97. What is the ratio of the Tax (as % of total tax revenue) of Austria in 2007 to that in 2009?
Give a very brief answer. 1.08. What is the ratio of the Tax (as % of total tax revenue) in Bangladesh in 2007 to that in 2009?
Your answer should be compact. 0.89. What is the ratio of the Tax (as % of total tax revenue) of Ireland in 2007 to that in 2009?
Keep it short and to the point. 1.01. What is the ratio of the Tax (as % of total tax revenue) of Portugal in 2007 to that in 2009?
Offer a terse response. 0.96. What is the ratio of the Tax (as % of total tax revenue) in Austria in 2008 to that in 2009?
Your answer should be very brief. 1.1. What is the ratio of the Tax (as % of total tax revenue) in Bangladesh in 2008 to that in 2009?
Provide a succinct answer. 0.95. What is the ratio of the Tax (as % of total tax revenue) in Portugal in 2008 to that in 2009?
Give a very brief answer. 0.99. What is the difference between the highest and the second highest Tax (as % of total tax revenue) of Austria?
Your response must be concise. 0.84. What is the difference between the highest and the second highest Tax (as % of total tax revenue) of Bangladesh?
Provide a short and direct response. 1.17. What is the difference between the highest and the second highest Tax (as % of total tax revenue) of Ireland?
Provide a succinct answer. 0.05. What is the difference between the highest and the second highest Tax (as % of total tax revenue) of Portugal?
Keep it short and to the point. 0.49. What is the difference between the highest and the lowest Tax (as % of total tax revenue) in Austria?
Your response must be concise. 4.38. What is the difference between the highest and the lowest Tax (as % of total tax revenue) of Bangladesh?
Provide a short and direct response. 9.56. What is the difference between the highest and the lowest Tax (as % of total tax revenue) of Ireland?
Offer a terse response. 1.23. What is the difference between the highest and the lowest Tax (as % of total tax revenue) of Portugal?
Keep it short and to the point. 4.73. 